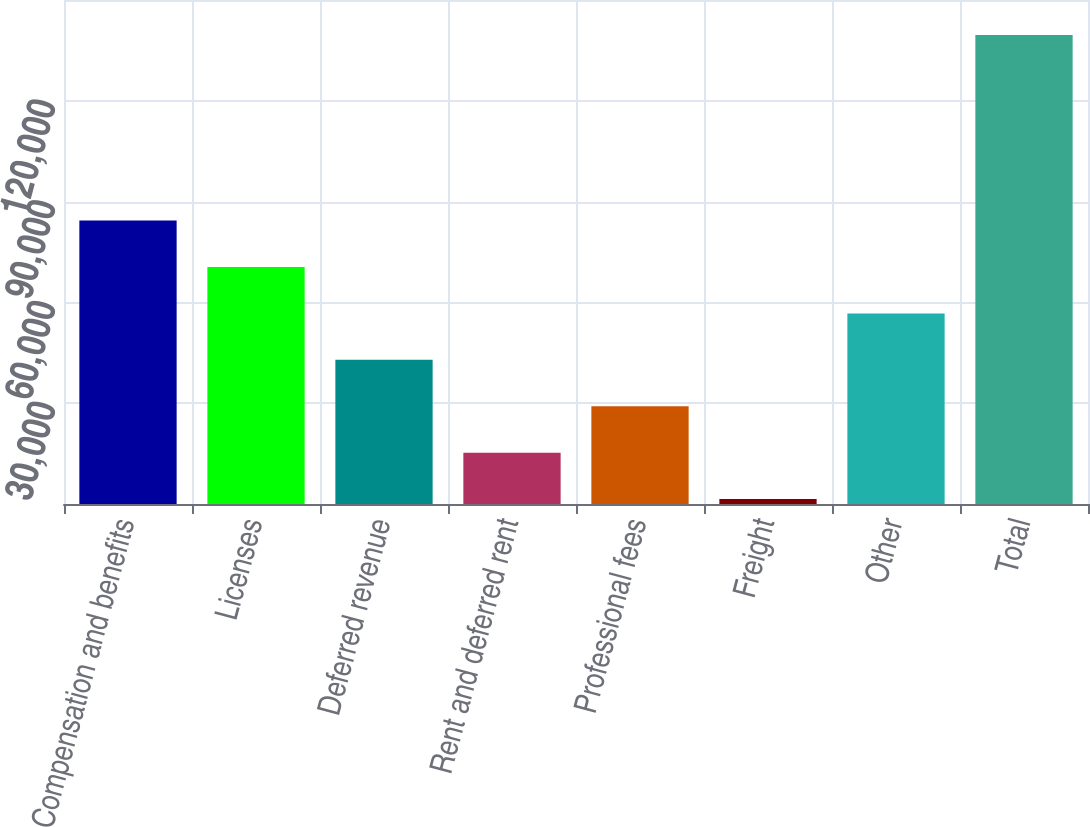<chart> <loc_0><loc_0><loc_500><loc_500><bar_chart><fcel>Compensation and benefits<fcel>Licenses<fcel>Deferred revenue<fcel>Rent and deferred rent<fcel>Professional fees<fcel>Freight<fcel>Other<fcel>Total<nl><fcel>84347.8<fcel>70535<fcel>42909.4<fcel>15283.8<fcel>29096.6<fcel>1471<fcel>56722.2<fcel>139599<nl></chart> 